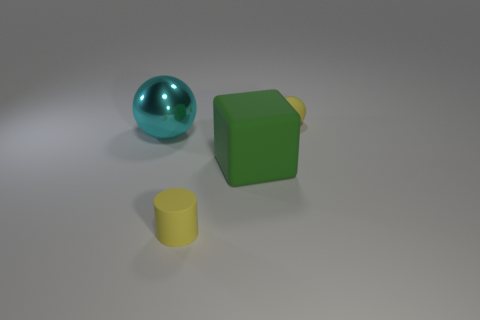Is the material of the tiny yellow object left of the small sphere the same as the large thing on the left side of the small yellow matte cylinder?
Ensure brevity in your answer.  No. There is a yellow matte object that is on the left side of the small rubber sphere; what is its size?
Your answer should be compact. Small. There is another object that is the same shape as the metal thing; what is its material?
Offer a very short reply. Rubber. There is a small yellow object that is behind the large shiny thing; what is its shape?
Your answer should be very brief. Sphere. How many big cyan shiny things are the same shape as the green thing?
Make the answer very short. 0. Are there the same number of big cyan metal things that are right of the large cyan thing and small yellow objects right of the large green rubber thing?
Give a very brief answer. No. Is there a tiny red sphere that has the same material as the large cyan ball?
Your answer should be very brief. No. Are the cylinder and the cyan thing made of the same material?
Make the answer very short. No. How many gray things are small rubber objects or cubes?
Provide a short and direct response. 0. Is the number of matte balls behind the tiny yellow cylinder greater than the number of cyan matte balls?
Provide a succinct answer. Yes. 